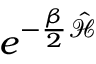<formula> <loc_0><loc_0><loc_500><loc_500>e ^ { - \frac { \beta } { 2 } \mathcal { \hat { H } } }</formula> 